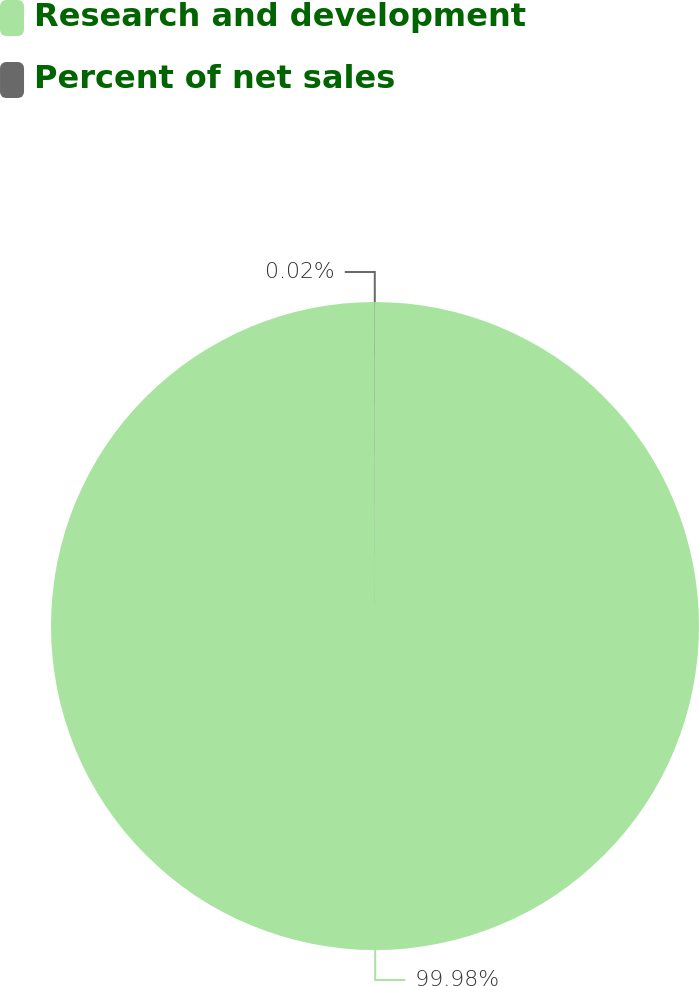Convert chart to OTSL. <chart><loc_0><loc_0><loc_500><loc_500><pie_chart><fcel>Research and development<fcel>Percent of net sales<nl><fcel>99.98%<fcel>0.02%<nl></chart> 